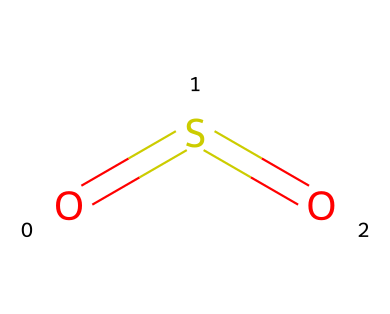What is the molecular formula of the compound? The compound consists of one sulfur (S) atom and two oxygen (O) atoms. The molecular formula is determined by counting the number of each type of atom present.
Answer: SO2 How many double bonds are present in the structure? The structure has one double bond between sulfur and each oxygen atom, which can be identified through the '=' symbols in the SMILES representation.
Answer: 2 What is the central atom in this molecule? In the structure O=S=O, sulfur is the central atom because it is bonded to both oxygen atoms and is at the center of the configuration.
Answer: sulfur Which element in this compound contributes to its acidity? The presence of oxygen atoms in the compound suggests that it can form acidic solutions when dissolved in water, contributing to its acidic nature.
Answer: oxygen What type of bonding is primarily present in sulfur dioxide? Sulfur dioxide primarily exhibits covalent bonding, as indicated by the shared electrons between sulfur and oxygen atoms, which is characteristic of molecular compounds.
Answer: covalent Is sulfur dioxide a polar or nonpolar molecule? Due to the bent shape of the molecule caused by the two lone pairs on sulfur, there is an unequal distribution of electron density, resulting in a polar molecule.
Answer: polar What atmospheric impact does sulfur dioxide have? Sulfur dioxide is a significant pollutant that contributes to acid rain formation and various respiratory problems in humans and animals.
Answer: acid rain 